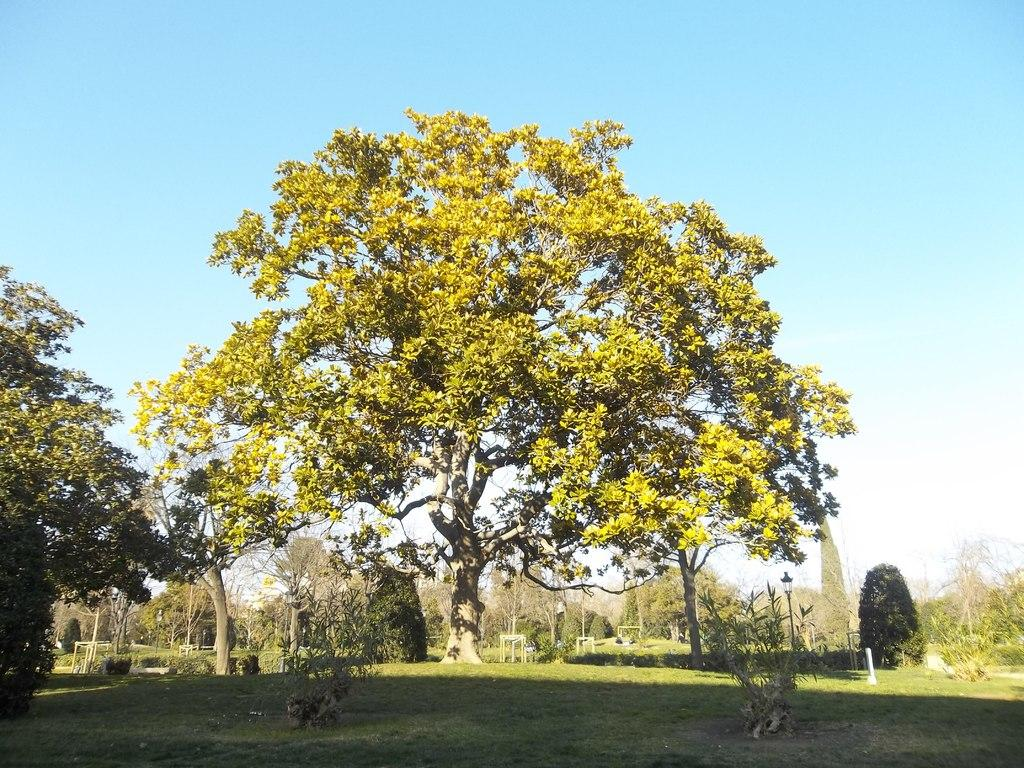What type of landscape is visible at the bottom of the image? There is grassland at the bottom side of the image. What can be seen in the center of the image? There are trees in the center of the image. What is visible at the top of the image? There is sky at the top side of the image. Can you see a branch being kissed by a person in the image? There is no branch or person present in the image, so this scenario cannot be observed. Is there a sidewalk visible in the image? There is no sidewalk present in the image; it features grassland, trees, and sky. 